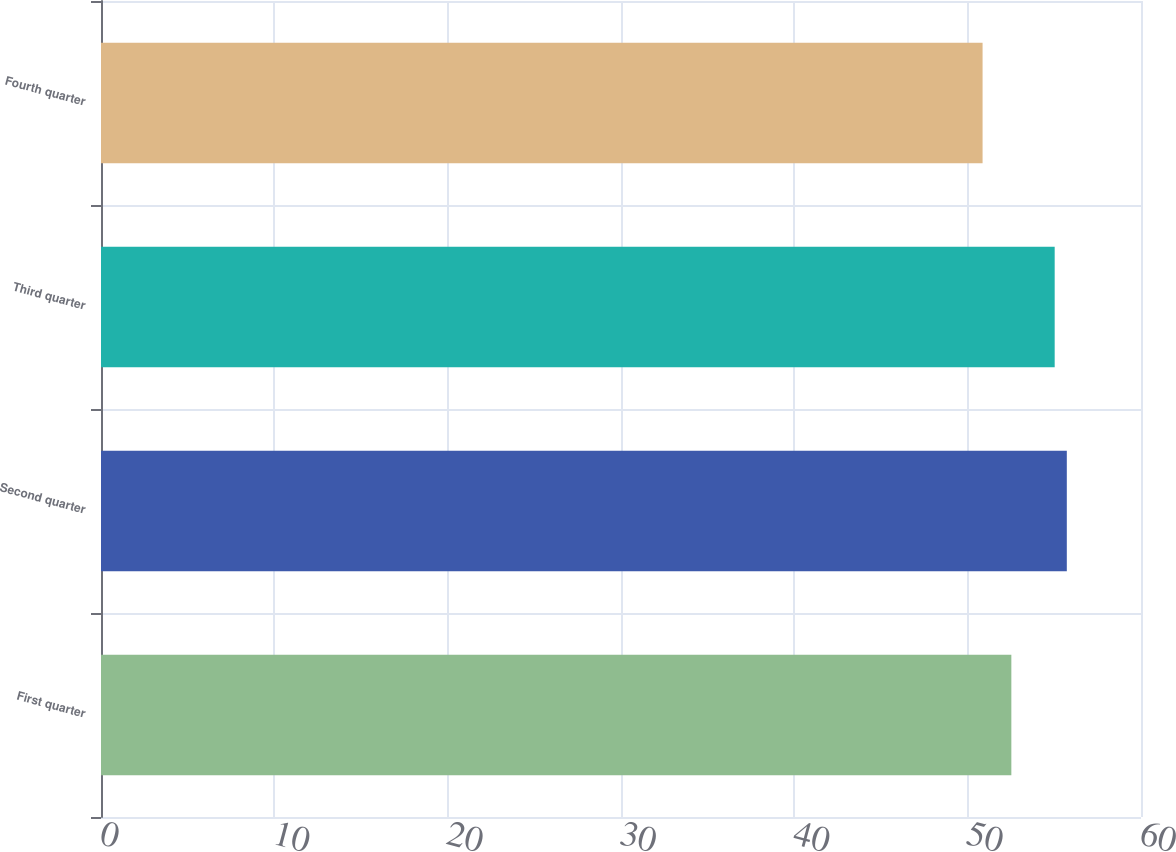<chart> <loc_0><loc_0><loc_500><loc_500><bar_chart><fcel>First quarter<fcel>Second quarter<fcel>Third quarter<fcel>Fourth quarter<nl><fcel>52.52<fcel>55.72<fcel>55.02<fcel>50.86<nl></chart> 